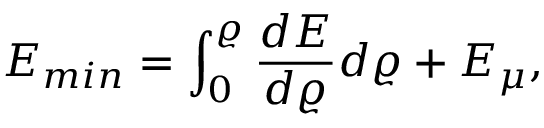Convert formula to latex. <formula><loc_0><loc_0><loc_500><loc_500>E _ { \min } = \int _ { 0 } ^ { \varrho } \frac { d E } { d \varrho } d \varrho + E _ { \mu } ,</formula> 